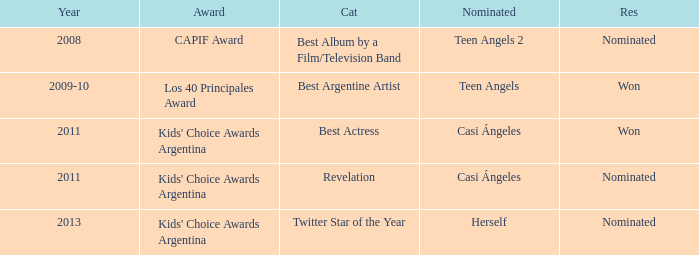Name the performance nominated for a Capif Award. Teen Angels 2. 